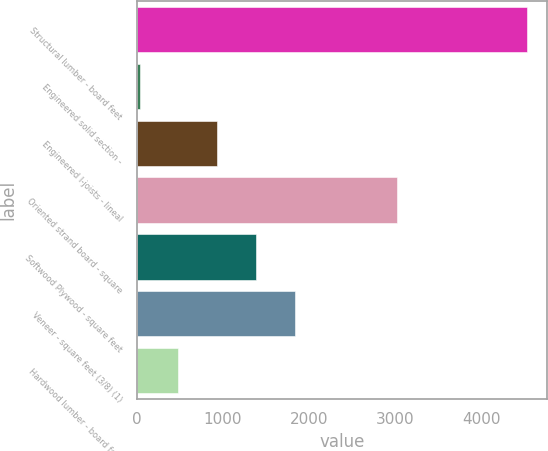Convert chart. <chart><loc_0><loc_0><loc_500><loc_500><bar_chart><fcel>Structural lumber - board feet<fcel>Engineered solid section -<fcel>Engineered I-joists - lineal<fcel>Oriented strand board - square<fcel>Softwood Plywood - square feet<fcel>Veneer - square feet (3/8) (1)<fcel>Hardwood lumber - board feet<nl><fcel>4530<fcel>37<fcel>935.6<fcel>3015<fcel>1384.9<fcel>1834.2<fcel>486.3<nl></chart> 